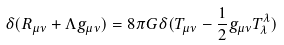<formula> <loc_0><loc_0><loc_500><loc_500>\delta ( R _ { \mu \nu } + \Lambda g _ { \mu \nu } ) = 8 \pi G \delta ( T _ { \mu \nu } - \frac { 1 } { 2 } g _ { \mu \nu } T ^ { \lambda } _ { \lambda } )</formula> 